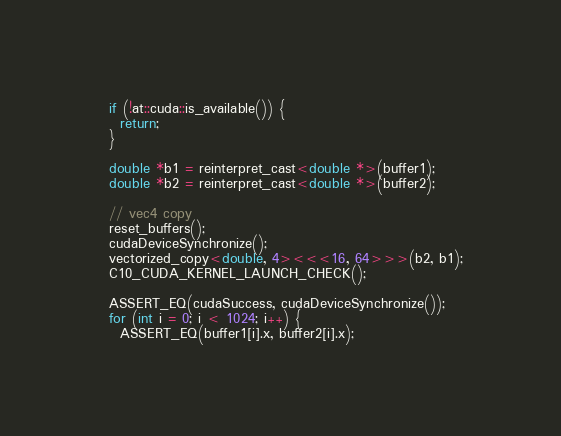<code> <loc_0><loc_0><loc_500><loc_500><_Cuda_>  if (!at::cuda::is_available()) {
    return;
  }

  double *b1 = reinterpret_cast<double *>(buffer1);
  double *b2 = reinterpret_cast<double *>(buffer2);

  // vec4 copy
  reset_buffers();
  cudaDeviceSynchronize();
  vectorized_copy<double, 4><<<16, 64>>>(b2, b1);
  C10_CUDA_KERNEL_LAUNCH_CHECK();

  ASSERT_EQ(cudaSuccess, cudaDeviceSynchronize());
  for (int i = 0; i < 1024; i++) {
    ASSERT_EQ(buffer1[i].x, buffer2[i].x);</code> 